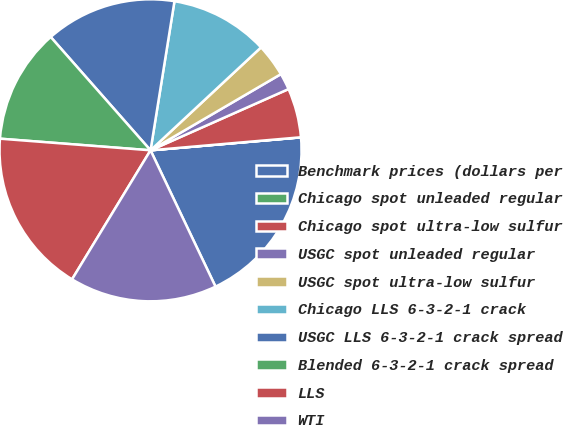<chart> <loc_0><loc_0><loc_500><loc_500><pie_chart><fcel>Benchmark prices (dollars per<fcel>Chicago spot unleaded regular<fcel>Chicago spot ultra-low sulfur<fcel>USGC spot unleaded regular<fcel>USGC spot ultra-low sulfur<fcel>Chicago LLS 6-3-2-1 crack<fcel>USGC LLS 6-3-2-1 crack spread<fcel>Blended 6-3-2-1 crack spread<fcel>LLS<fcel>WTI<nl><fcel>19.29%<fcel>0.01%<fcel>5.27%<fcel>1.77%<fcel>3.52%<fcel>10.53%<fcel>14.03%<fcel>12.28%<fcel>17.53%<fcel>15.78%<nl></chart> 